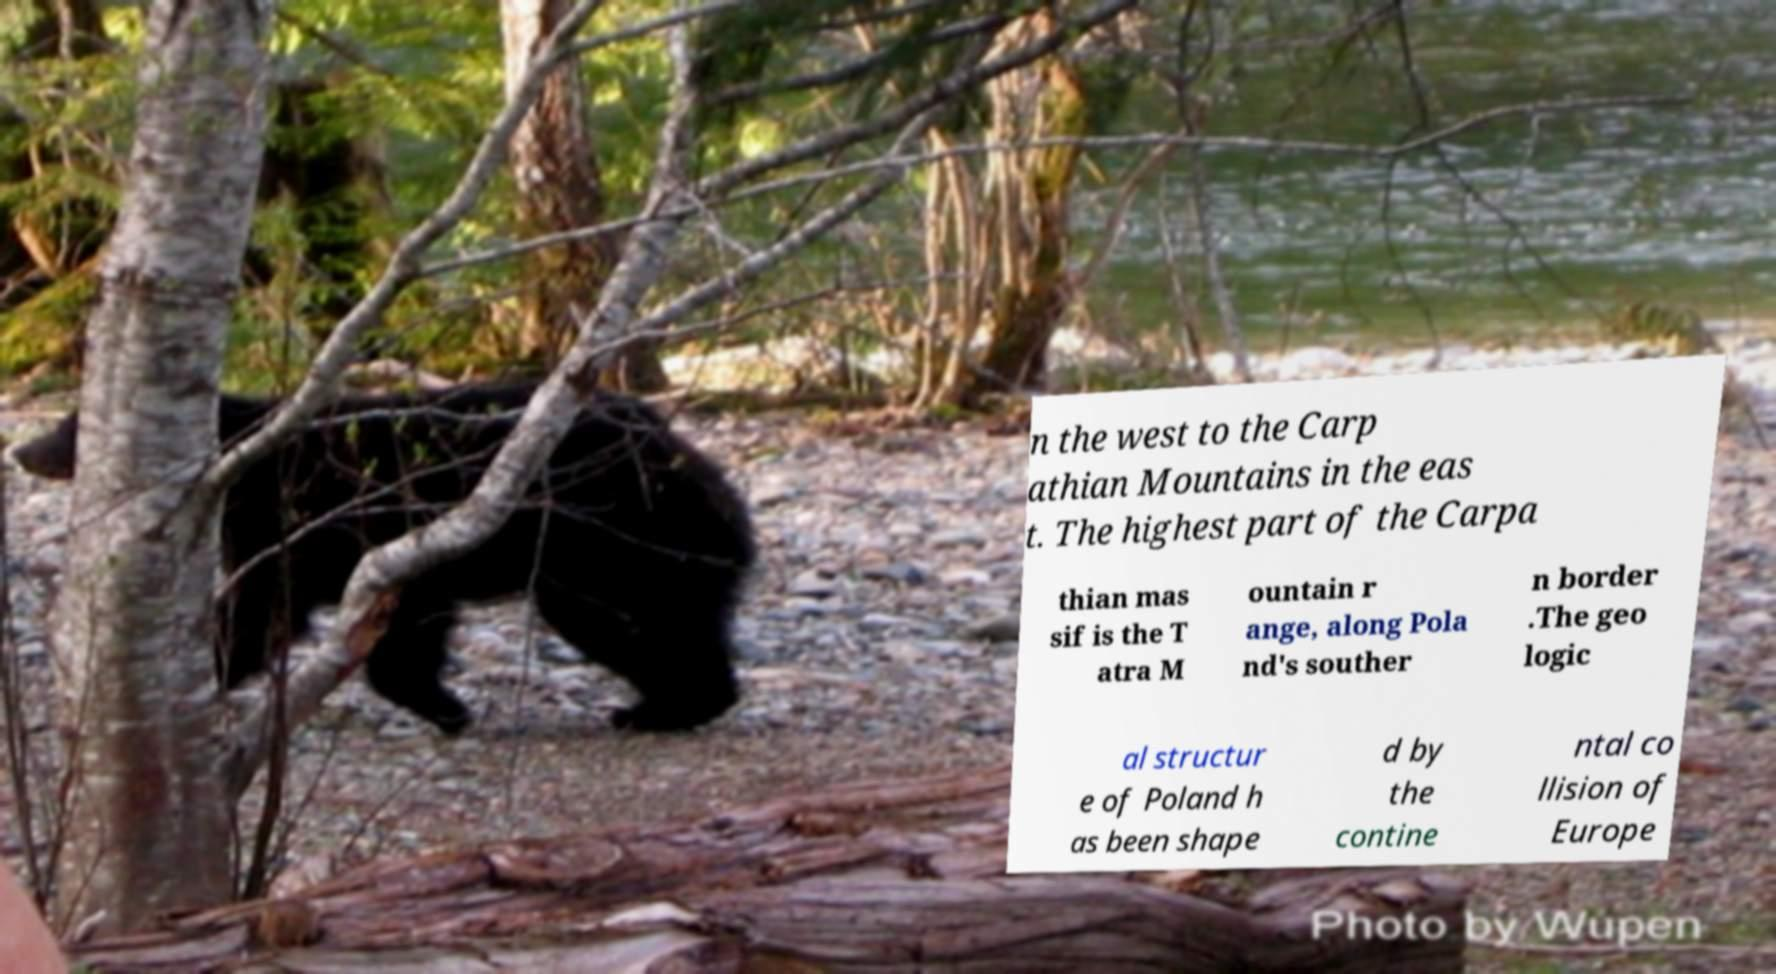There's text embedded in this image that I need extracted. Can you transcribe it verbatim? n the west to the Carp athian Mountains in the eas t. The highest part of the Carpa thian mas sif is the T atra M ountain r ange, along Pola nd's souther n border .The geo logic al structur e of Poland h as been shape d by the contine ntal co llision of Europe 